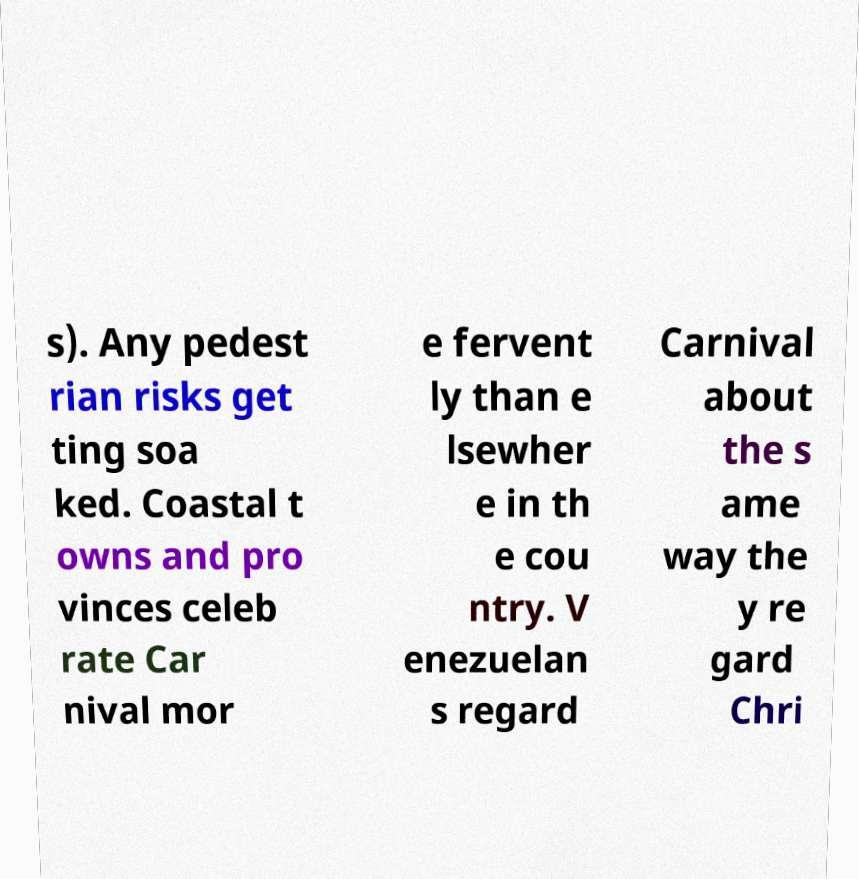Please identify and transcribe the text found in this image. s). Any pedest rian risks get ting soa ked. Coastal t owns and pro vinces celeb rate Car nival mor e fervent ly than e lsewher e in th e cou ntry. V enezuelan s regard Carnival about the s ame way the y re gard Chri 